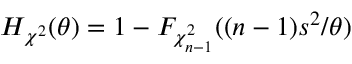Convert formula to latex. <formula><loc_0><loc_0><loc_500><loc_500>H _ { \chi ^ { 2 } } ( \theta ) = 1 - F _ { \chi _ { n - 1 } ^ { 2 } } ( ( n - 1 ) s ^ { 2 } / \theta )</formula> 